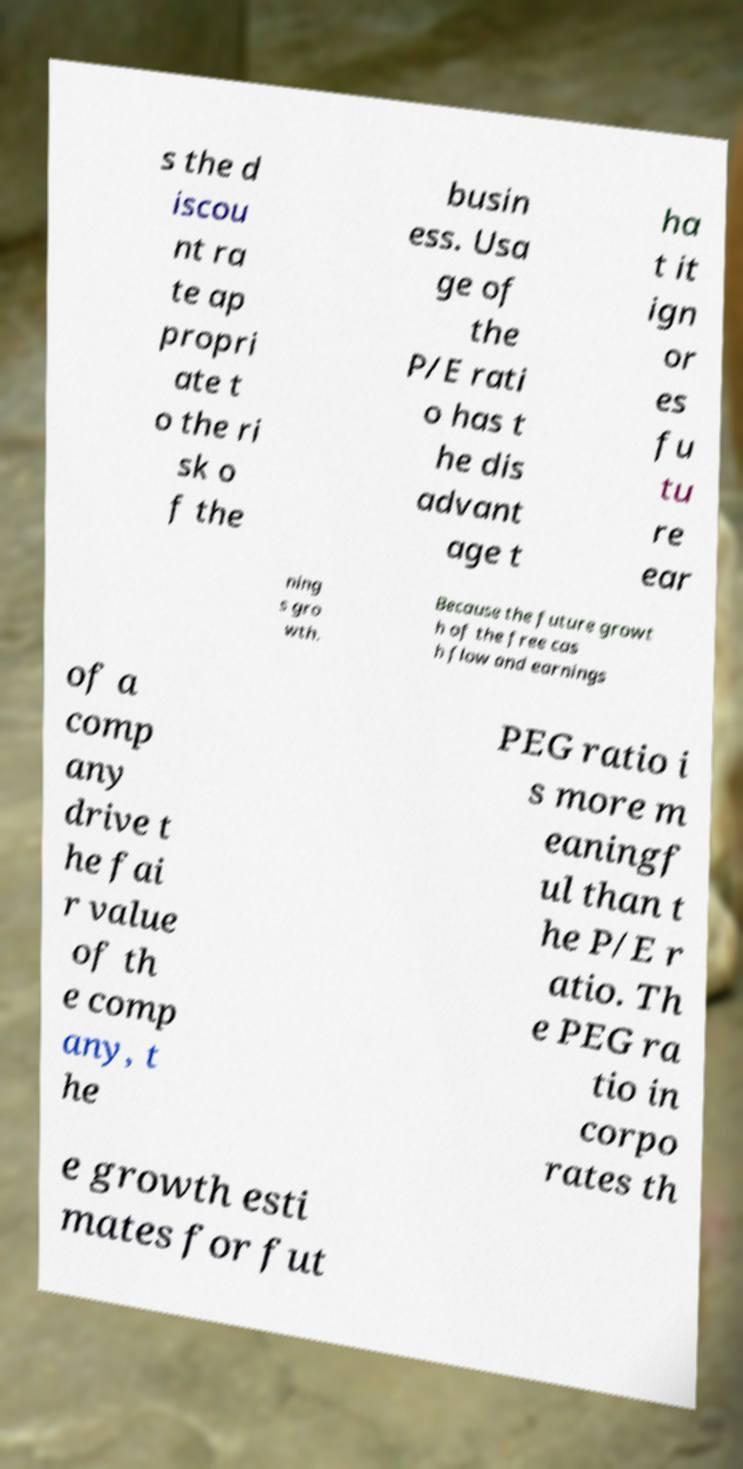Can you accurately transcribe the text from the provided image for me? s the d iscou nt ra te ap propri ate t o the ri sk o f the busin ess. Usa ge of the P/E rati o has t he dis advant age t ha t it ign or es fu tu re ear ning s gro wth. Because the future growt h of the free cas h flow and earnings of a comp any drive t he fai r value of th e comp any, t he PEG ratio i s more m eaningf ul than t he P/E r atio. Th e PEG ra tio in corpo rates th e growth esti mates for fut 